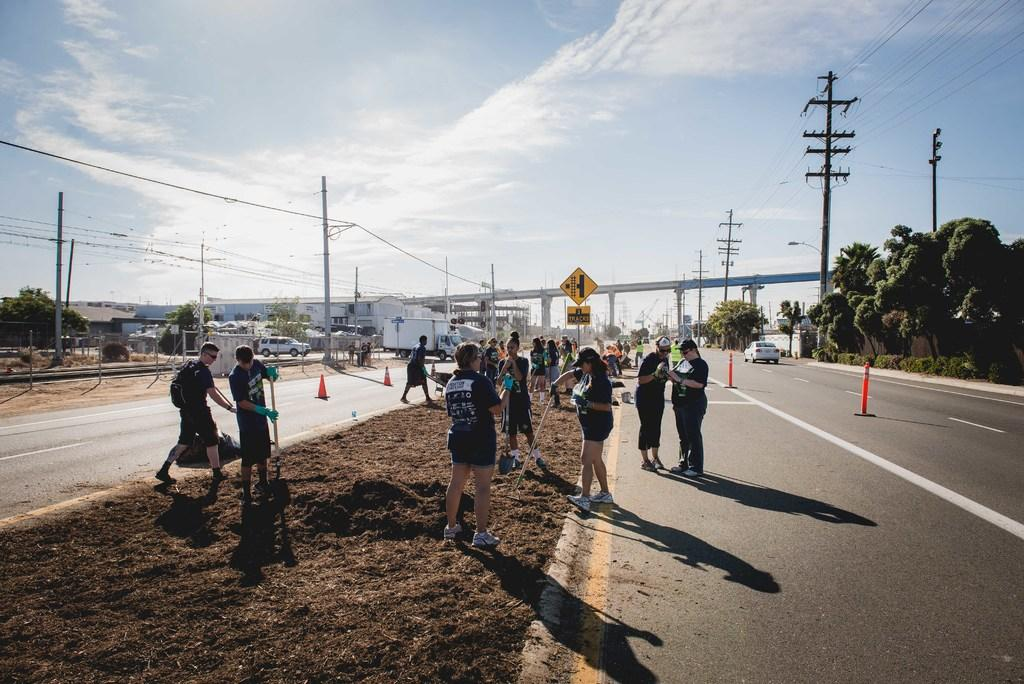How many people can be seen in the image? There are people in the image, but the exact number is not specified. What objects are present in the image that are used for traffic control? Traffic cones are present in the image for traffic control. What type of structures can be seen in the image that are used for support? Rods and poles are visible in the image and are used for support. What types of vehicles are in the image? Vehicles are in the image, but the specific types are not specified. What type of natural vegetation is visible in the image? Trees are visible in the image. What type of man-made structures are present in the image? Wires and houses are present in the image. What type of infrastructure is in the image that allows people and vehicles to cross bodies of water? There is a bridge in the image that allows people and vehicles to cross bodies of water. What is visible in the background of the image? The sky is visible in the background of the image. What type of weather can be inferred from the image? Clouds are present in the sky, suggesting that the weather might be partly cloudy. What type of grape is being used to hold up the bridge in the image? There are no grapes present in the image, and they are not used to hold up the bridge. What type of copper material can be seen in the image? There is no copper material present in the image. 